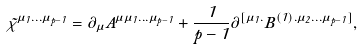Convert formula to latex. <formula><loc_0><loc_0><loc_500><loc_500>\tilde { \chi } ^ { \mu _ { 1 } \dots \mu _ { p - 1 } } = \partial _ { \mu } A ^ { \mu \mu _ { 1 } \dots \mu _ { p - 1 } } + \frac { 1 } { p - 1 } \partial ^ { [ \mu _ { 1 } . } B ^ { ( 1 ) . \mu _ { 2 } \dots \mu _ { p - 1 } ] } ,</formula> 